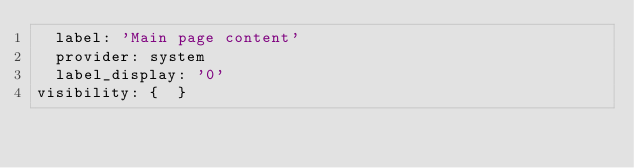Convert code to text. <code><loc_0><loc_0><loc_500><loc_500><_YAML_>  label: 'Main page content'
  provider: system
  label_display: '0'
visibility: {  }
</code> 